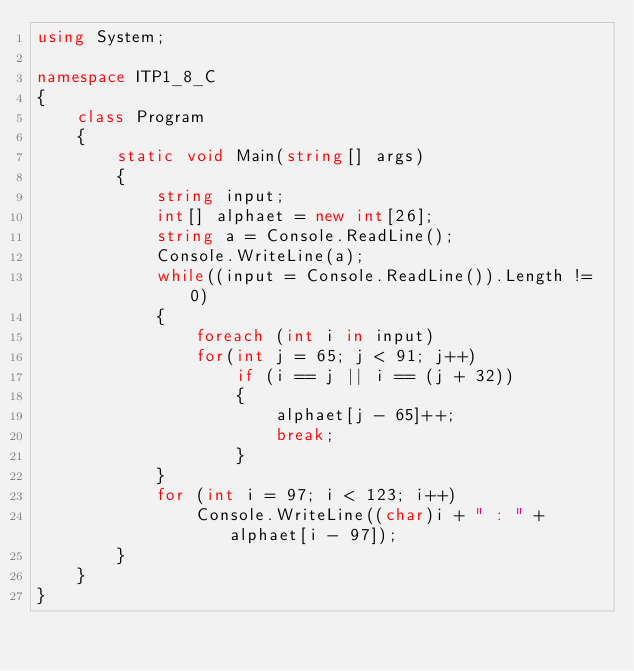Convert code to text. <code><loc_0><loc_0><loc_500><loc_500><_C#_>using System;

namespace ITP1_8_C
{
    class Program
    {
        static void Main(string[] args)
        {
            string input;
            int[] alphaet = new int[26];
            string a = Console.ReadLine();
            Console.WriteLine(a);
            while((input = Console.ReadLine()).Length != 0)
            {
                foreach (int i in input)
                for(int j = 65; j < 91; j++)
                    if (i == j || i == (j + 32))
                    {
                        alphaet[j - 65]++;
                        break;
                    }
            }           
            for (int i = 97; i < 123; i++)
                Console.WriteLine((char)i + " : " + alphaet[i - 97]);
        }
    }
}</code> 